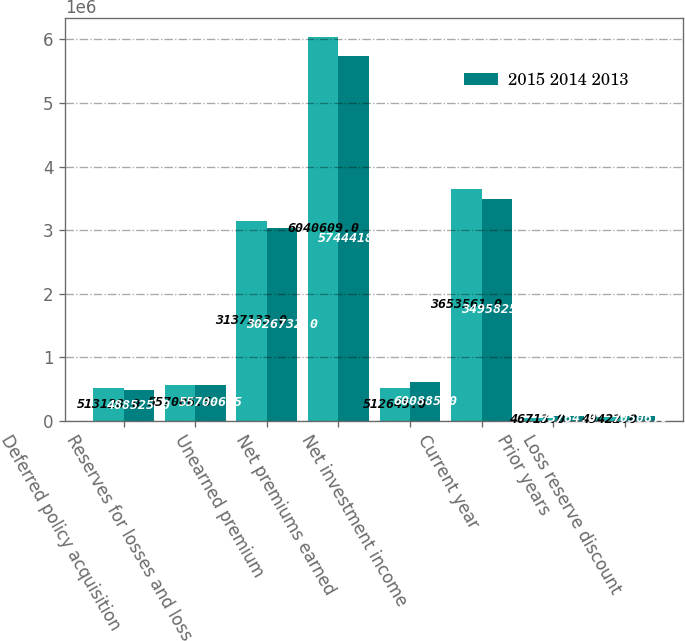Convert chart to OTSL. <chart><loc_0><loc_0><loc_500><loc_500><stacked_bar_chart><ecel><fcel>Deferred policy acquisition<fcel>Reserves for losses and loss<fcel>Unearned premium<fcel>Net premiums earned<fcel>Net investment income<fcel>Current year<fcel>Prior years<fcel>Loss reserve discount<nl><fcel>nan<fcel>513128<fcel>557006<fcel>3.13713e+06<fcel>6.04061e+06<fcel>512645<fcel>3.65356e+06<fcel>46713<fcel>49422<nl><fcel>2015 2014 2013<fcel>488525<fcel>557006<fcel>3.02673e+06<fcel>5.74442e+06<fcel>600885<fcel>3.49582e+06<fcel>75764<fcel>70506<nl></chart> 